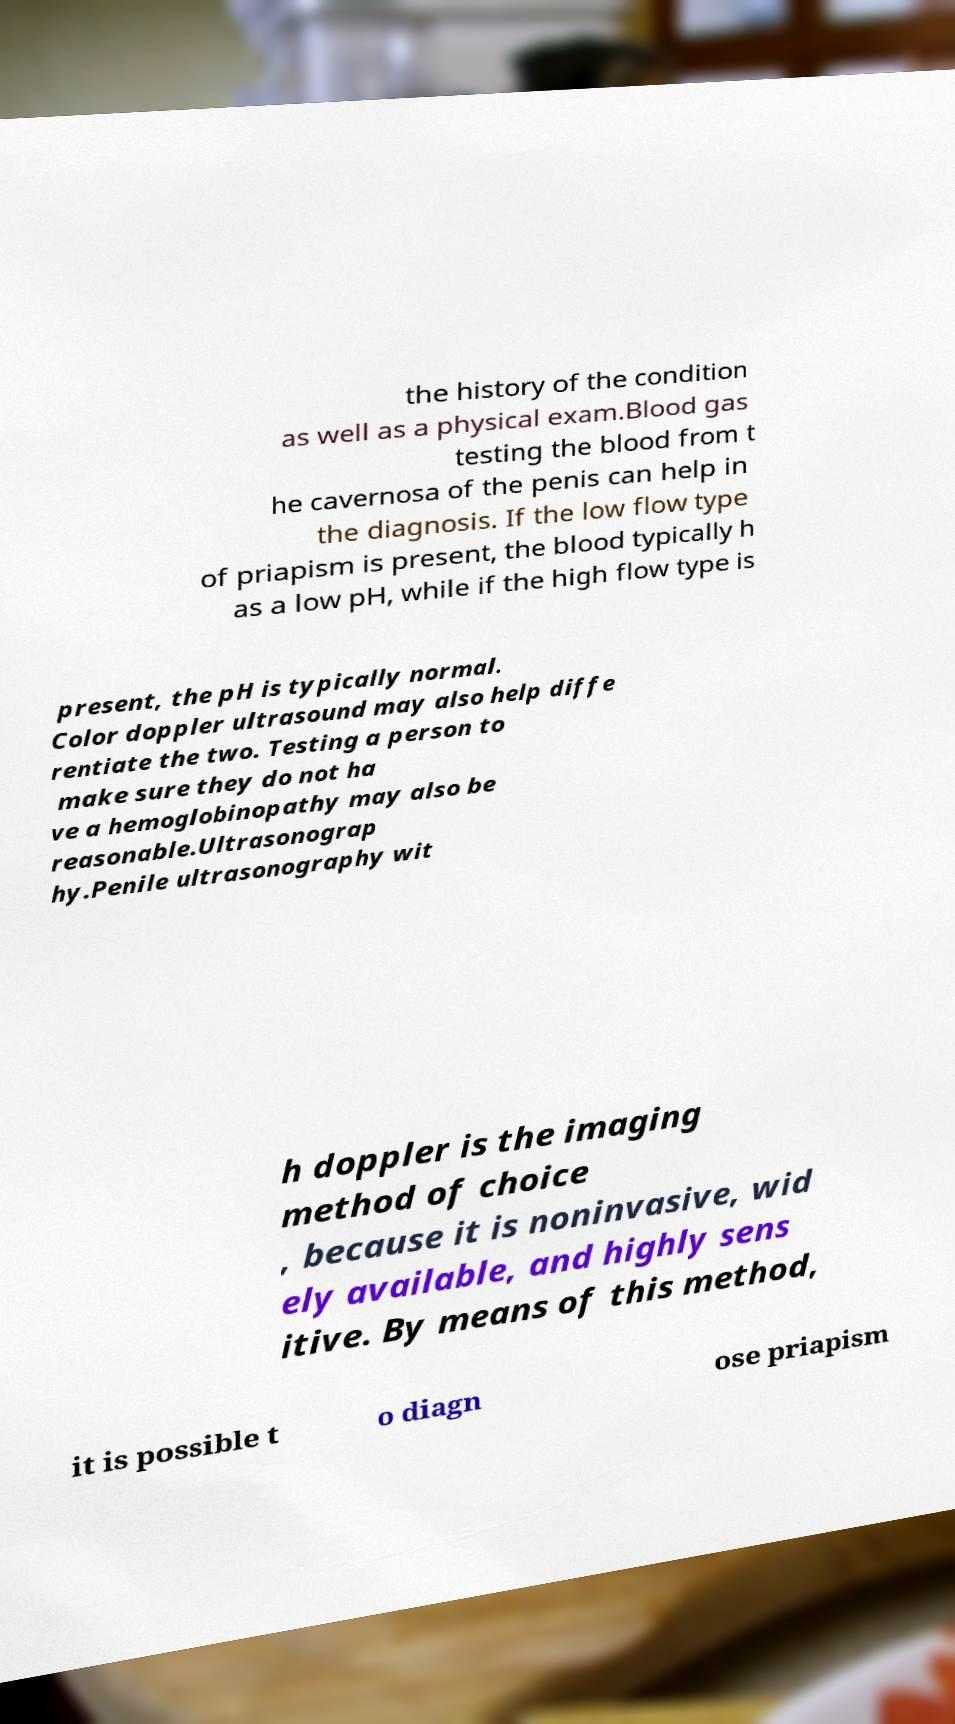For documentation purposes, I need the text within this image transcribed. Could you provide that? the history of the condition as well as a physical exam.Blood gas testing the blood from t he cavernosa of the penis can help in the diagnosis. If the low flow type of priapism is present, the blood typically h as a low pH, while if the high flow type is present, the pH is typically normal. Color doppler ultrasound may also help diffe rentiate the two. Testing a person to make sure they do not ha ve a hemoglobinopathy may also be reasonable.Ultrasonograp hy.Penile ultrasonography wit h doppler is the imaging method of choice , because it is noninvasive, wid ely available, and highly sens itive. By means of this method, it is possible t o diagn ose priapism 